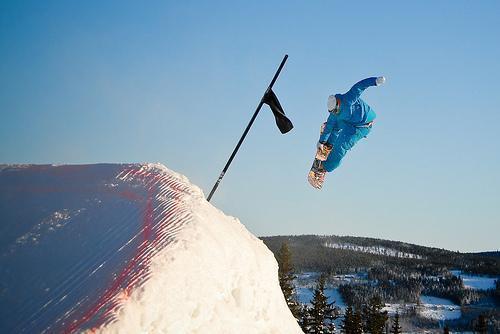How many people are in this photo?
Give a very brief answer. 1. 